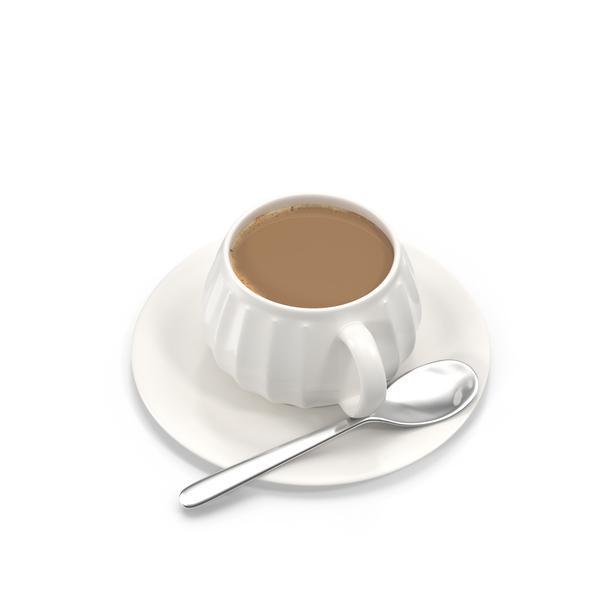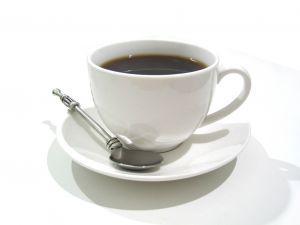The first image is the image on the left, the second image is the image on the right. Examine the images to the left and right. Is the description "In one image, there is no spoon laid next to the cup on the plate." accurate? Answer yes or no. No. The first image is the image on the left, the second image is the image on the right. Given the left and right images, does the statement "Full cups of coffee sit on matching saucers with a spoon." hold true? Answer yes or no. Yes. 